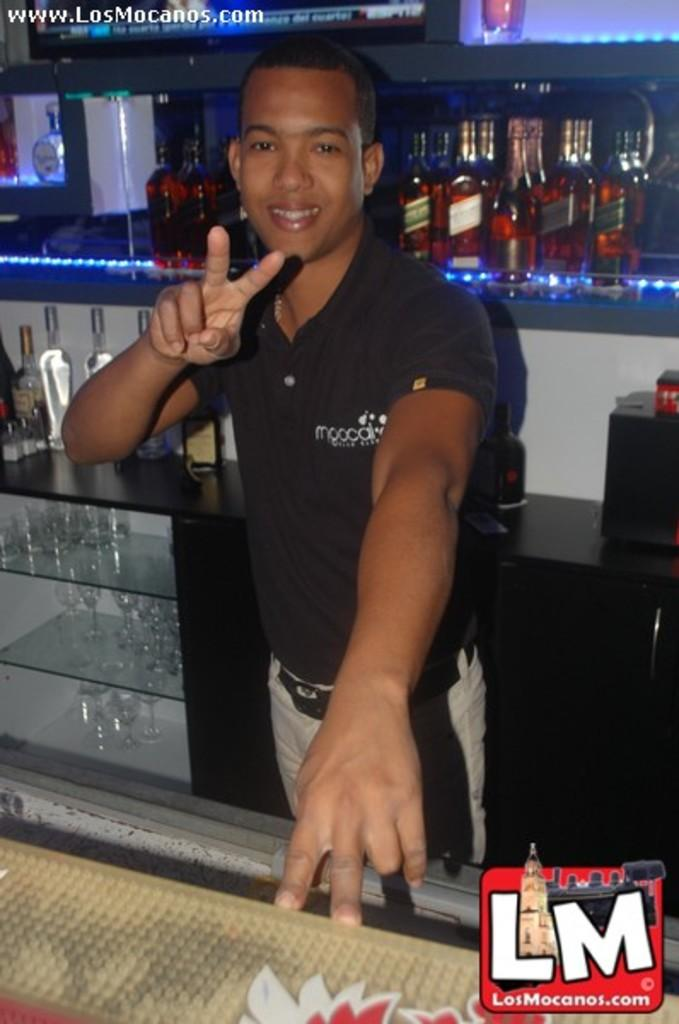Who is present in the image? There is a man in the image. What is the man wearing? The man is wearing a black t-shirt. What objects can be seen in the image besides the man? There are bottles, glasses, and shelves in the image. How many visitors can be seen in the image? There are no visitors present in the image; it only features a man. What type of bit is being used by the man in the image? There is no bit present in the image, as it does not involve any bit-related activities. 